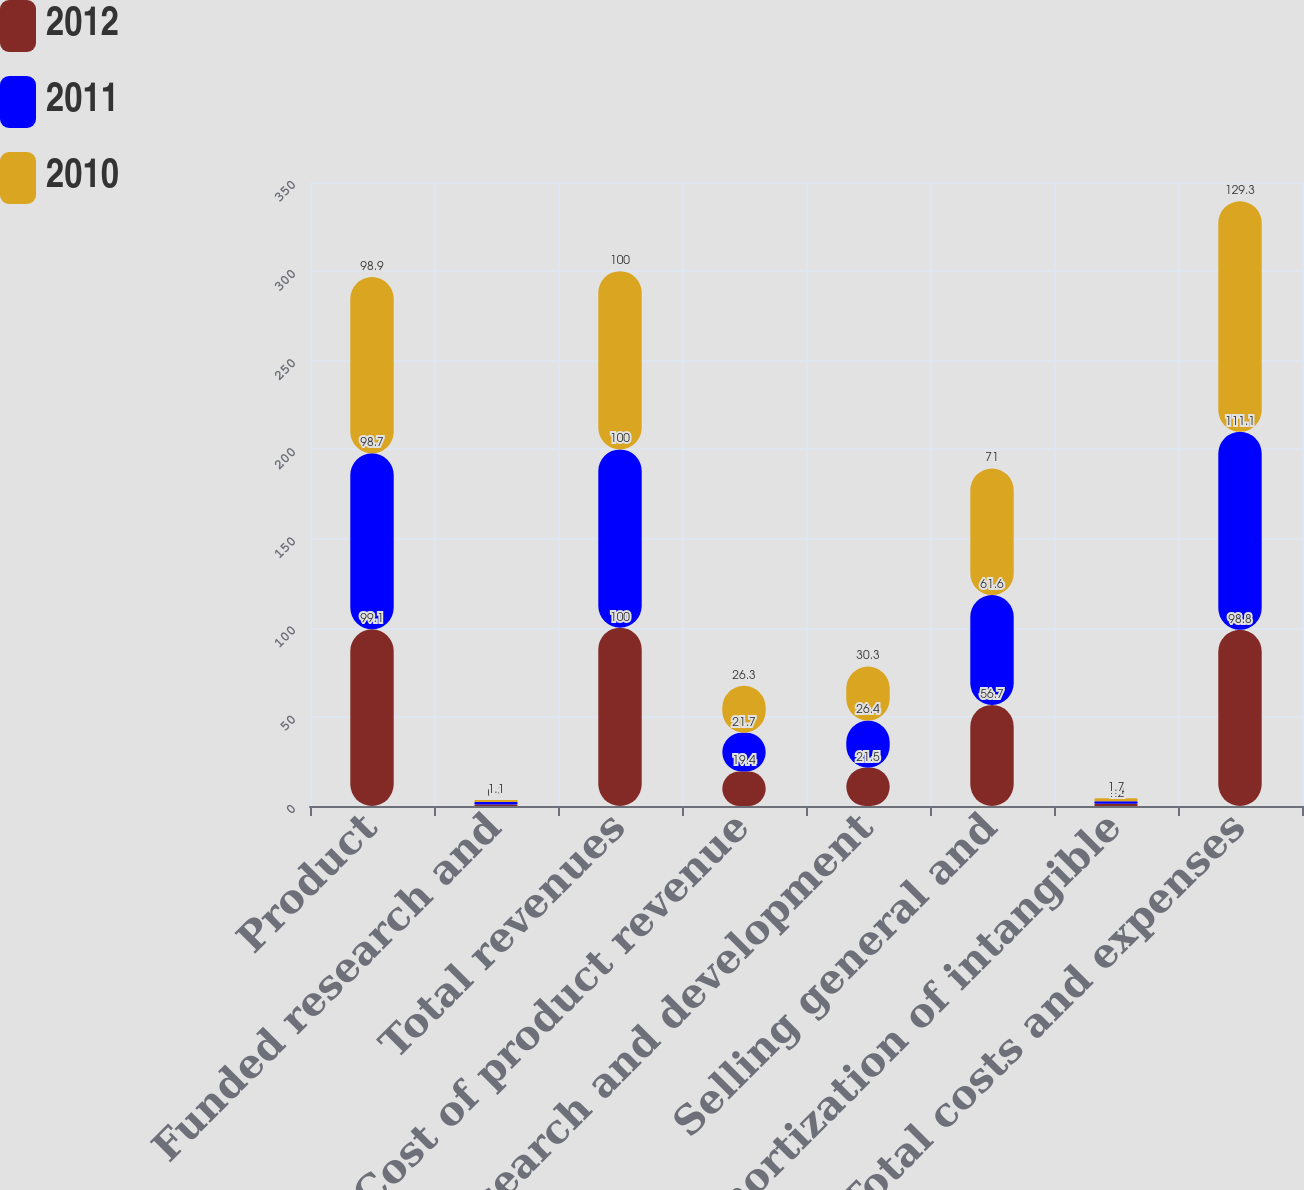Convert chart. <chart><loc_0><loc_0><loc_500><loc_500><stacked_bar_chart><ecel><fcel>Product<fcel>Funded research and<fcel>Total revenues<fcel>Cost of product revenue<fcel>Research and development<fcel>Selling general and<fcel>Amortization of intangible<fcel>Total costs and expenses<nl><fcel>2012<fcel>99.1<fcel>0.9<fcel>100<fcel>19.4<fcel>21.5<fcel>56.7<fcel>1.2<fcel>98.8<nl><fcel>2011<fcel>98.7<fcel>1.3<fcel>100<fcel>21.7<fcel>26.4<fcel>61.6<fcel>1.4<fcel>111.1<nl><fcel>2010<fcel>98.9<fcel>1.1<fcel>100<fcel>26.3<fcel>30.3<fcel>71<fcel>1.7<fcel>129.3<nl></chart> 